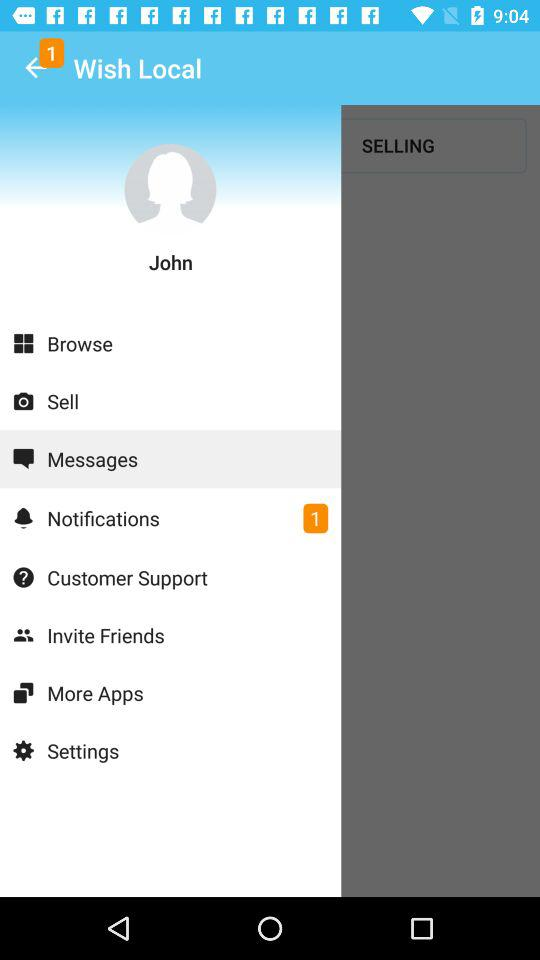What is the user name? The user name is John. 